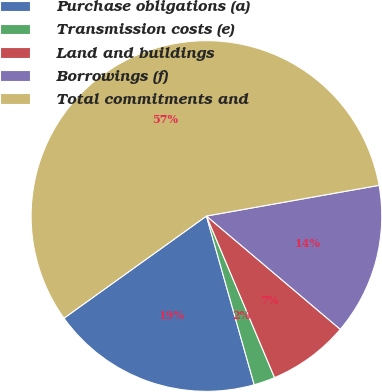Convert chart. <chart><loc_0><loc_0><loc_500><loc_500><pie_chart><fcel>Purchase obligations (a)<fcel>Transmission costs (e)<fcel>Land and buildings<fcel>Borrowings (f)<fcel>Total commitments and<nl><fcel>19.49%<fcel>1.96%<fcel>7.47%<fcel>13.98%<fcel>57.1%<nl></chart> 